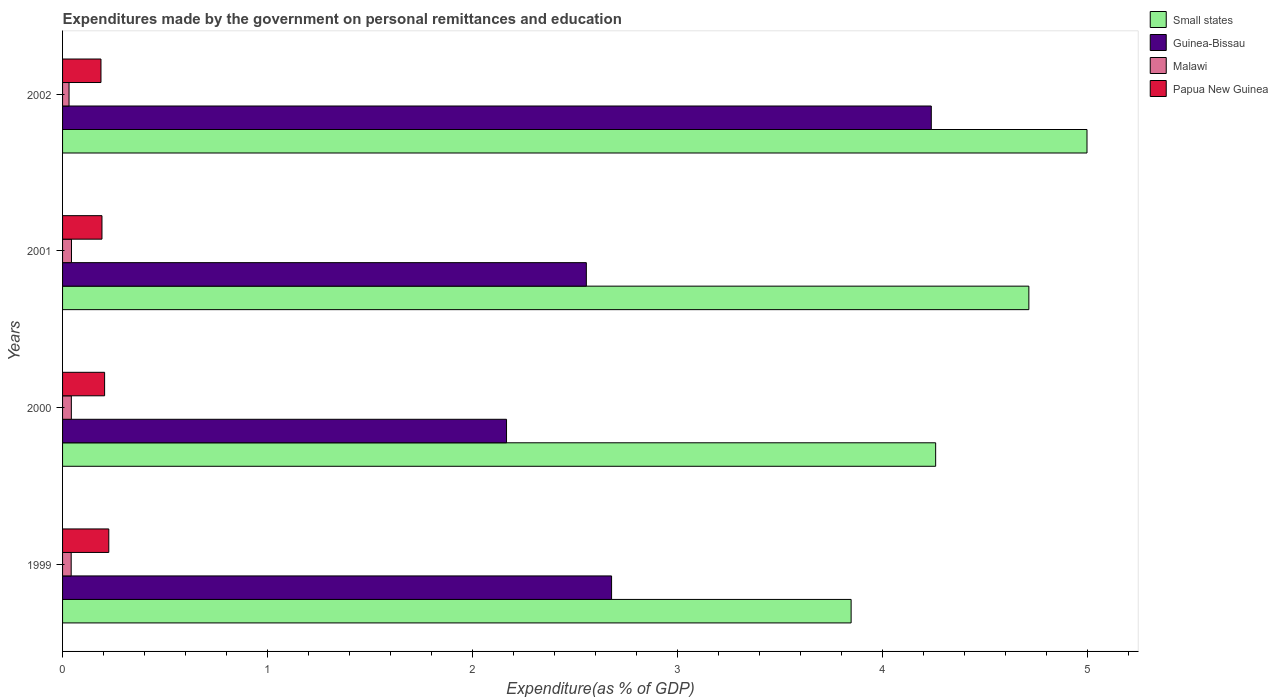How many groups of bars are there?
Your answer should be compact. 4. Are the number of bars per tick equal to the number of legend labels?
Keep it short and to the point. Yes. Are the number of bars on each tick of the Y-axis equal?
Your answer should be very brief. Yes. What is the label of the 4th group of bars from the top?
Offer a terse response. 1999. In how many cases, is the number of bars for a given year not equal to the number of legend labels?
Give a very brief answer. 0. What is the expenditures made by the government on personal remittances and education in Small states in 1999?
Keep it short and to the point. 3.85. Across all years, what is the maximum expenditures made by the government on personal remittances and education in Malawi?
Provide a succinct answer. 0.04. Across all years, what is the minimum expenditures made by the government on personal remittances and education in Papua New Guinea?
Offer a terse response. 0.19. In which year was the expenditures made by the government on personal remittances and education in Malawi maximum?
Your answer should be compact. 2001. In which year was the expenditures made by the government on personal remittances and education in Malawi minimum?
Offer a terse response. 2002. What is the total expenditures made by the government on personal remittances and education in Papua New Guinea in the graph?
Your answer should be compact. 0.81. What is the difference between the expenditures made by the government on personal remittances and education in Malawi in 2001 and that in 2002?
Make the answer very short. 0.01. What is the difference between the expenditures made by the government on personal remittances and education in Malawi in 2000 and the expenditures made by the government on personal remittances and education in Papua New Guinea in 2002?
Your answer should be compact. -0.14. What is the average expenditures made by the government on personal remittances and education in Guinea-Bissau per year?
Make the answer very short. 2.91. In the year 2000, what is the difference between the expenditures made by the government on personal remittances and education in Small states and expenditures made by the government on personal remittances and education in Malawi?
Offer a terse response. 4.22. What is the ratio of the expenditures made by the government on personal remittances and education in Papua New Guinea in 2000 to that in 2002?
Ensure brevity in your answer.  1.09. Is the difference between the expenditures made by the government on personal remittances and education in Small states in 2001 and 2002 greater than the difference between the expenditures made by the government on personal remittances and education in Malawi in 2001 and 2002?
Offer a terse response. No. What is the difference between the highest and the second highest expenditures made by the government on personal remittances and education in Malawi?
Provide a short and direct response. 0. What is the difference between the highest and the lowest expenditures made by the government on personal remittances and education in Small states?
Provide a succinct answer. 1.15. In how many years, is the expenditures made by the government on personal remittances and education in Small states greater than the average expenditures made by the government on personal remittances and education in Small states taken over all years?
Provide a short and direct response. 2. Is the sum of the expenditures made by the government on personal remittances and education in Papua New Guinea in 1999 and 2001 greater than the maximum expenditures made by the government on personal remittances and education in Small states across all years?
Ensure brevity in your answer.  No. Is it the case that in every year, the sum of the expenditures made by the government on personal remittances and education in Papua New Guinea and expenditures made by the government on personal remittances and education in Malawi is greater than the sum of expenditures made by the government on personal remittances and education in Small states and expenditures made by the government on personal remittances and education in Guinea-Bissau?
Offer a terse response. Yes. What does the 1st bar from the top in 2001 represents?
Your response must be concise. Papua New Guinea. What does the 3rd bar from the bottom in 2001 represents?
Offer a very short reply. Malawi. Is it the case that in every year, the sum of the expenditures made by the government on personal remittances and education in Small states and expenditures made by the government on personal remittances and education in Papua New Guinea is greater than the expenditures made by the government on personal remittances and education in Guinea-Bissau?
Offer a very short reply. Yes. Are all the bars in the graph horizontal?
Keep it short and to the point. Yes. How many years are there in the graph?
Provide a succinct answer. 4. Are the values on the major ticks of X-axis written in scientific E-notation?
Your answer should be very brief. No. Does the graph contain any zero values?
Your response must be concise. No. How many legend labels are there?
Provide a short and direct response. 4. How are the legend labels stacked?
Offer a terse response. Vertical. What is the title of the graph?
Offer a very short reply. Expenditures made by the government on personal remittances and education. What is the label or title of the X-axis?
Your answer should be very brief. Expenditure(as % of GDP). What is the label or title of the Y-axis?
Offer a terse response. Years. What is the Expenditure(as % of GDP) of Small states in 1999?
Give a very brief answer. 3.85. What is the Expenditure(as % of GDP) in Guinea-Bissau in 1999?
Ensure brevity in your answer.  2.68. What is the Expenditure(as % of GDP) of Malawi in 1999?
Provide a short and direct response. 0.04. What is the Expenditure(as % of GDP) of Papua New Guinea in 1999?
Your answer should be compact. 0.23. What is the Expenditure(as % of GDP) in Small states in 2000?
Provide a succinct answer. 4.26. What is the Expenditure(as % of GDP) in Guinea-Bissau in 2000?
Offer a very short reply. 2.17. What is the Expenditure(as % of GDP) of Malawi in 2000?
Provide a succinct answer. 0.04. What is the Expenditure(as % of GDP) of Papua New Guinea in 2000?
Make the answer very short. 0.21. What is the Expenditure(as % of GDP) of Small states in 2001?
Provide a short and direct response. 4.72. What is the Expenditure(as % of GDP) in Guinea-Bissau in 2001?
Your answer should be compact. 2.56. What is the Expenditure(as % of GDP) in Malawi in 2001?
Provide a short and direct response. 0.04. What is the Expenditure(as % of GDP) of Papua New Guinea in 2001?
Your answer should be compact. 0.19. What is the Expenditure(as % of GDP) of Small states in 2002?
Offer a terse response. 5. What is the Expenditure(as % of GDP) in Guinea-Bissau in 2002?
Make the answer very short. 4.24. What is the Expenditure(as % of GDP) of Malawi in 2002?
Offer a terse response. 0.03. What is the Expenditure(as % of GDP) in Papua New Guinea in 2002?
Ensure brevity in your answer.  0.19. Across all years, what is the maximum Expenditure(as % of GDP) of Small states?
Offer a very short reply. 5. Across all years, what is the maximum Expenditure(as % of GDP) in Guinea-Bissau?
Offer a terse response. 4.24. Across all years, what is the maximum Expenditure(as % of GDP) of Malawi?
Offer a very short reply. 0.04. Across all years, what is the maximum Expenditure(as % of GDP) in Papua New Guinea?
Your response must be concise. 0.23. Across all years, what is the minimum Expenditure(as % of GDP) of Small states?
Keep it short and to the point. 3.85. Across all years, what is the minimum Expenditure(as % of GDP) of Guinea-Bissau?
Offer a very short reply. 2.17. Across all years, what is the minimum Expenditure(as % of GDP) of Malawi?
Make the answer very short. 0.03. Across all years, what is the minimum Expenditure(as % of GDP) of Papua New Guinea?
Give a very brief answer. 0.19. What is the total Expenditure(as % of GDP) in Small states in the graph?
Offer a terse response. 17.83. What is the total Expenditure(as % of GDP) in Guinea-Bissau in the graph?
Keep it short and to the point. 11.64. What is the total Expenditure(as % of GDP) of Malawi in the graph?
Keep it short and to the point. 0.16. What is the total Expenditure(as % of GDP) in Papua New Guinea in the graph?
Your answer should be compact. 0.81. What is the difference between the Expenditure(as % of GDP) of Small states in 1999 and that in 2000?
Your response must be concise. -0.41. What is the difference between the Expenditure(as % of GDP) of Guinea-Bissau in 1999 and that in 2000?
Offer a very short reply. 0.51. What is the difference between the Expenditure(as % of GDP) of Malawi in 1999 and that in 2000?
Your answer should be very brief. -0. What is the difference between the Expenditure(as % of GDP) of Papua New Guinea in 1999 and that in 2000?
Provide a short and direct response. 0.02. What is the difference between the Expenditure(as % of GDP) in Small states in 1999 and that in 2001?
Provide a succinct answer. -0.87. What is the difference between the Expenditure(as % of GDP) of Guinea-Bissau in 1999 and that in 2001?
Make the answer very short. 0.12. What is the difference between the Expenditure(as % of GDP) of Malawi in 1999 and that in 2001?
Your answer should be very brief. -0. What is the difference between the Expenditure(as % of GDP) of Papua New Guinea in 1999 and that in 2001?
Your response must be concise. 0.03. What is the difference between the Expenditure(as % of GDP) of Small states in 1999 and that in 2002?
Offer a terse response. -1.15. What is the difference between the Expenditure(as % of GDP) of Guinea-Bissau in 1999 and that in 2002?
Your response must be concise. -1.56. What is the difference between the Expenditure(as % of GDP) in Malawi in 1999 and that in 2002?
Your answer should be very brief. 0.01. What is the difference between the Expenditure(as % of GDP) in Papua New Guinea in 1999 and that in 2002?
Provide a short and direct response. 0.04. What is the difference between the Expenditure(as % of GDP) of Small states in 2000 and that in 2001?
Your response must be concise. -0.45. What is the difference between the Expenditure(as % of GDP) in Guinea-Bissau in 2000 and that in 2001?
Offer a terse response. -0.39. What is the difference between the Expenditure(as % of GDP) of Malawi in 2000 and that in 2001?
Your answer should be compact. -0. What is the difference between the Expenditure(as % of GDP) in Papua New Guinea in 2000 and that in 2001?
Offer a very short reply. 0.01. What is the difference between the Expenditure(as % of GDP) of Small states in 2000 and that in 2002?
Make the answer very short. -0.74. What is the difference between the Expenditure(as % of GDP) of Guinea-Bissau in 2000 and that in 2002?
Give a very brief answer. -2.07. What is the difference between the Expenditure(as % of GDP) in Malawi in 2000 and that in 2002?
Make the answer very short. 0.01. What is the difference between the Expenditure(as % of GDP) of Papua New Guinea in 2000 and that in 2002?
Provide a succinct answer. 0.02. What is the difference between the Expenditure(as % of GDP) in Small states in 2001 and that in 2002?
Provide a succinct answer. -0.28. What is the difference between the Expenditure(as % of GDP) in Guinea-Bissau in 2001 and that in 2002?
Provide a succinct answer. -1.68. What is the difference between the Expenditure(as % of GDP) of Malawi in 2001 and that in 2002?
Provide a short and direct response. 0.01. What is the difference between the Expenditure(as % of GDP) of Papua New Guinea in 2001 and that in 2002?
Make the answer very short. 0. What is the difference between the Expenditure(as % of GDP) of Small states in 1999 and the Expenditure(as % of GDP) of Guinea-Bissau in 2000?
Offer a very short reply. 1.68. What is the difference between the Expenditure(as % of GDP) in Small states in 1999 and the Expenditure(as % of GDP) in Malawi in 2000?
Your answer should be compact. 3.81. What is the difference between the Expenditure(as % of GDP) of Small states in 1999 and the Expenditure(as % of GDP) of Papua New Guinea in 2000?
Make the answer very short. 3.64. What is the difference between the Expenditure(as % of GDP) of Guinea-Bissau in 1999 and the Expenditure(as % of GDP) of Malawi in 2000?
Give a very brief answer. 2.64. What is the difference between the Expenditure(as % of GDP) of Guinea-Bissau in 1999 and the Expenditure(as % of GDP) of Papua New Guinea in 2000?
Give a very brief answer. 2.47. What is the difference between the Expenditure(as % of GDP) of Malawi in 1999 and the Expenditure(as % of GDP) of Papua New Guinea in 2000?
Offer a very short reply. -0.16. What is the difference between the Expenditure(as % of GDP) of Small states in 1999 and the Expenditure(as % of GDP) of Guinea-Bissau in 2001?
Make the answer very short. 1.29. What is the difference between the Expenditure(as % of GDP) of Small states in 1999 and the Expenditure(as % of GDP) of Malawi in 2001?
Make the answer very short. 3.81. What is the difference between the Expenditure(as % of GDP) in Small states in 1999 and the Expenditure(as % of GDP) in Papua New Guinea in 2001?
Provide a succinct answer. 3.66. What is the difference between the Expenditure(as % of GDP) of Guinea-Bissau in 1999 and the Expenditure(as % of GDP) of Malawi in 2001?
Give a very brief answer. 2.64. What is the difference between the Expenditure(as % of GDP) in Guinea-Bissau in 1999 and the Expenditure(as % of GDP) in Papua New Guinea in 2001?
Give a very brief answer. 2.49. What is the difference between the Expenditure(as % of GDP) of Malawi in 1999 and the Expenditure(as % of GDP) of Papua New Guinea in 2001?
Give a very brief answer. -0.15. What is the difference between the Expenditure(as % of GDP) of Small states in 1999 and the Expenditure(as % of GDP) of Guinea-Bissau in 2002?
Offer a very short reply. -0.39. What is the difference between the Expenditure(as % of GDP) in Small states in 1999 and the Expenditure(as % of GDP) in Malawi in 2002?
Keep it short and to the point. 3.82. What is the difference between the Expenditure(as % of GDP) of Small states in 1999 and the Expenditure(as % of GDP) of Papua New Guinea in 2002?
Offer a very short reply. 3.66. What is the difference between the Expenditure(as % of GDP) of Guinea-Bissau in 1999 and the Expenditure(as % of GDP) of Malawi in 2002?
Provide a succinct answer. 2.65. What is the difference between the Expenditure(as % of GDP) of Guinea-Bissau in 1999 and the Expenditure(as % of GDP) of Papua New Guinea in 2002?
Your answer should be very brief. 2.49. What is the difference between the Expenditure(as % of GDP) in Malawi in 1999 and the Expenditure(as % of GDP) in Papua New Guinea in 2002?
Keep it short and to the point. -0.15. What is the difference between the Expenditure(as % of GDP) in Small states in 2000 and the Expenditure(as % of GDP) in Guinea-Bissau in 2001?
Provide a short and direct response. 1.7. What is the difference between the Expenditure(as % of GDP) in Small states in 2000 and the Expenditure(as % of GDP) in Malawi in 2001?
Offer a very short reply. 4.22. What is the difference between the Expenditure(as % of GDP) of Small states in 2000 and the Expenditure(as % of GDP) of Papua New Guinea in 2001?
Your response must be concise. 4.07. What is the difference between the Expenditure(as % of GDP) of Guinea-Bissau in 2000 and the Expenditure(as % of GDP) of Malawi in 2001?
Provide a short and direct response. 2.12. What is the difference between the Expenditure(as % of GDP) of Guinea-Bissau in 2000 and the Expenditure(as % of GDP) of Papua New Guinea in 2001?
Make the answer very short. 1.97. What is the difference between the Expenditure(as % of GDP) of Malawi in 2000 and the Expenditure(as % of GDP) of Papua New Guinea in 2001?
Make the answer very short. -0.15. What is the difference between the Expenditure(as % of GDP) of Small states in 2000 and the Expenditure(as % of GDP) of Guinea-Bissau in 2002?
Give a very brief answer. 0.02. What is the difference between the Expenditure(as % of GDP) of Small states in 2000 and the Expenditure(as % of GDP) of Malawi in 2002?
Your answer should be very brief. 4.23. What is the difference between the Expenditure(as % of GDP) in Small states in 2000 and the Expenditure(as % of GDP) in Papua New Guinea in 2002?
Your response must be concise. 4.07. What is the difference between the Expenditure(as % of GDP) in Guinea-Bissau in 2000 and the Expenditure(as % of GDP) in Malawi in 2002?
Keep it short and to the point. 2.14. What is the difference between the Expenditure(as % of GDP) in Guinea-Bissau in 2000 and the Expenditure(as % of GDP) in Papua New Guinea in 2002?
Keep it short and to the point. 1.98. What is the difference between the Expenditure(as % of GDP) of Malawi in 2000 and the Expenditure(as % of GDP) of Papua New Guinea in 2002?
Offer a very short reply. -0.14. What is the difference between the Expenditure(as % of GDP) of Small states in 2001 and the Expenditure(as % of GDP) of Guinea-Bissau in 2002?
Provide a succinct answer. 0.48. What is the difference between the Expenditure(as % of GDP) in Small states in 2001 and the Expenditure(as % of GDP) in Malawi in 2002?
Offer a terse response. 4.68. What is the difference between the Expenditure(as % of GDP) of Small states in 2001 and the Expenditure(as % of GDP) of Papua New Guinea in 2002?
Your response must be concise. 4.53. What is the difference between the Expenditure(as % of GDP) in Guinea-Bissau in 2001 and the Expenditure(as % of GDP) in Malawi in 2002?
Your answer should be compact. 2.52. What is the difference between the Expenditure(as % of GDP) in Guinea-Bissau in 2001 and the Expenditure(as % of GDP) in Papua New Guinea in 2002?
Provide a short and direct response. 2.37. What is the difference between the Expenditure(as % of GDP) of Malawi in 2001 and the Expenditure(as % of GDP) of Papua New Guinea in 2002?
Ensure brevity in your answer.  -0.14. What is the average Expenditure(as % of GDP) in Small states per year?
Offer a very short reply. 4.46. What is the average Expenditure(as % of GDP) of Guinea-Bissau per year?
Offer a terse response. 2.91. What is the average Expenditure(as % of GDP) in Malawi per year?
Make the answer very short. 0.04. What is the average Expenditure(as % of GDP) of Papua New Guinea per year?
Give a very brief answer. 0.2. In the year 1999, what is the difference between the Expenditure(as % of GDP) in Small states and Expenditure(as % of GDP) in Guinea-Bissau?
Your response must be concise. 1.17. In the year 1999, what is the difference between the Expenditure(as % of GDP) of Small states and Expenditure(as % of GDP) of Malawi?
Provide a short and direct response. 3.81. In the year 1999, what is the difference between the Expenditure(as % of GDP) of Small states and Expenditure(as % of GDP) of Papua New Guinea?
Ensure brevity in your answer.  3.62. In the year 1999, what is the difference between the Expenditure(as % of GDP) in Guinea-Bissau and Expenditure(as % of GDP) in Malawi?
Offer a terse response. 2.64. In the year 1999, what is the difference between the Expenditure(as % of GDP) in Guinea-Bissau and Expenditure(as % of GDP) in Papua New Guinea?
Your answer should be very brief. 2.45. In the year 1999, what is the difference between the Expenditure(as % of GDP) in Malawi and Expenditure(as % of GDP) in Papua New Guinea?
Offer a terse response. -0.18. In the year 2000, what is the difference between the Expenditure(as % of GDP) of Small states and Expenditure(as % of GDP) of Guinea-Bissau?
Keep it short and to the point. 2.09. In the year 2000, what is the difference between the Expenditure(as % of GDP) of Small states and Expenditure(as % of GDP) of Malawi?
Give a very brief answer. 4.22. In the year 2000, what is the difference between the Expenditure(as % of GDP) of Small states and Expenditure(as % of GDP) of Papua New Guinea?
Give a very brief answer. 4.06. In the year 2000, what is the difference between the Expenditure(as % of GDP) in Guinea-Bissau and Expenditure(as % of GDP) in Malawi?
Your answer should be very brief. 2.12. In the year 2000, what is the difference between the Expenditure(as % of GDP) in Guinea-Bissau and Expenditure(as % of GDP) in Papua New Guinea?
Offer a terse response. 1.96. In the year 2000, what is the difference between the Expenditure(as % of GDP) in Malawi and Expenditure(as % of GDP) in Papua New Guinea?
Your answer should be very brief. -0.16. In the year 2001, what is the difference between the Expenditure(as % of GDP) in Small states and Expenditure(as % of GDP) in Guinea-Bissau?
Offer a terse response. 2.16. In the year 2001, what is the difference between the Expenditure(as % of GDP) of Small states and Expenditure(as % of GDP) of Malawi?
Offer a terse response. 4.67. In the year 2001, what is the difference between the Expenditure(as % of GDP) of Small states and Expenditure(as % of GDP) of Papua New Guinea?
Your answer should be very brief. 4.52. In the year 2001, what is the difference between the Expenditure(as % of GDP) of Guinea-Bissau and Expenditure(as % of GDP) of Malawi?
Your answer should be compact. 2.51. In the year 2001, what is the difference between the Expenditure(as % of GDP) in Guinea-Bissau and Expenditure(as % of GDP) in Papua New Guinea?
Offer a terse response. 2.36. In the year 2001, what is the difference between the Expenditure(as % of GDP) in Malawi and Expenditure(as % of GDP) in Papua New Guinea?
Keep it short and to the point. -0.15. In the year 2002, what is the difference between the Expenditure(as % of GDP) in Small states and Expenditure(as % of GDP) in Guinea-Bissau?
Provide a succinct answer. 0.76. In the year 2002, what is the difference between the Expenditure(as % of GDP) in Small states and Expenditure(as % of GDP) in Malawi?
Your answer should be compact. 4.97. In the year 2002, what is the difference between the Expenditure(as % of GDP) of Small states and Expenditure(as % of GDP) of Papua New Guinea?
Your answer should be very brief. 4.81. In the year 2002, what is the difference between the Expenditure(as % of GDP) in Guinea-Bissau and Expenditure(as % of GDP) in Malawi?
Offer a terse response. 4.21. In the year 2002, what is the difference between the Expenditure(as % of GDP) in Guinea-Bissau and Expenditure(as % of GDP) in Papua New Guinea?
Provide a succinct answer. 4.05. In the year 2002, what is the difference between the Expenditure(as % of GDP) of Malawi and Expenditure(as % of GDP) of Papua New Guinea?
Give a very brief answer. -0.16. What is the ratio of the Expenditure(as % of GDP) in Small states in 1999 to that in 2000?
Offer a very short reply. 0.9. What is the ratio of the Expenditure(as % of GDP) in Guinea-Bissau in 1999 to that in 2000?
Give a very brief answer. 1.24. What is the ratio of the Expenditure(as % of GDP) of Malawi in 1999 to that in 2000?
Keep it short and to the point. 0.98. What is the ratio of the Expenditure(as % of GDP) of Papua New Guinea in 1999 to that in 2000?
Ensure brevity in your answer.  1.1. What is the ratio of the Expenditure(as % of GDP) in Small states in 1999 to that in 2001?
Provide a short and direct response. 0.82. What is the ratio of the Expenditure(as % of GDP) of Guinea-Bissau in 1999 to that in 2001?
Offer a very short reply. 1.05. What is the ratio of the Expenditure(as % of GDP) in Malawi in 1999 to that in 2001?
Offer a very short reply. 0.97. What is the ratio of the Expenditure(as % of GDP) of Papua New Guinea in 1999 to that in 2001?
Provide a succinct answer. 1.17. What is the ratio of the Expenditure(as % of GDP) in Small states in 1999 to that in 2002?
Offer a terse response. 0.77. What is the ratio of the Expenditure(as % of GDP) in Guinea-Bissau in 1999 to that in 2002?
Your answer should be compact. 0.63. What is the ratio of the Expenditure(as % of GDP) in Malawi in 1999 to that in 2002?
Your answer should be compact. 1.33. What is the ratio of the Expenditure(as % of GDP) in Papua New Guinea in 1999 to that in 2002?
Provide a short and direct response. 1.2. What is the ratio of the Expenditure(as % of GDP) of Small states in 2000 to that in 2001?
Provide a succinct answer. 0.9. What is the ratio of the Expenditure(as % of GDP) of Guinea-Bissau in 2000 to that in 2001?
Your response must be concise. 0.85. What is the ratio of the Expenditure(as % of GDP) in Malawi in 2000 to that in 2001?
Provide a succinct answer. 0.98. What is the ratio of the Expenditure(as % of GDP) in Papua New Guinea in 2000 to that in 2001?
Provide a short and direct response. 1.07. What is the ratio of the Expenditure(as % of GDP) of Small states in 2000 to that in 2002?
Your answer should be compact. 0.85. What is the ratio of the Expenditure(as % of GDP) of Guinea-Bissau in 2000 to that in 2002?
Keep it short and to the point. 0.51. What is the ratio of the Expenditure(as % of GDP) in Malawi in 2000 to that in 2002?
Keep it short and to the point. 1.35. What is the ratio of the Expenditure(as % of GDP) of Papua New Guinea in 2000 to that in 2002?
Offer a very short reply. 1.09. What is the ratio of the Expenditure(as % of GDP) of Small states in 2001 to that in 2002?
Give a very brief answer. 0.94. What is the ratio of the Expenditure(as % of GDP) in Guinea-Bissau in 2001 to that in 2002?
Provide a short and direct response. 0.6. What is the ratio of the Expenditure(as % of GDP) in Malawi in 2001 to that in 2002?
Offer a terse response. 1.37. What is the ratio of the Expenditure(as % of GDP) of Papua New Guinea in 2001 to that in 2002?
Your answer should be compact. 1.03. What is the difference between the highest and the second highest Expenditure(as % of GDP) of Small states?
Ensure brevity in your answer.  0.28. What is the difference between the highest and the second highest Expenditure(as % of GDP) in Guinea-Bissau?
Your answer should be very brief. 1.56. What is the difference between the highest and the second highest Expenditure(as % of GDP) of Malawi?
Provide a short and direct response. 0. What is the difference between the highest and the second highest Expenditure(as % of GDP) in Papua New Guinea?
Provide a short and direct response. 0.02. What is the difference between the highest and the lowest Expenditure(as % of GDP) in Small states?
Keep it short and to the point. 1.15. What is the difference between the highest and the lowest Expenditure(as % of GDP) in Guinea-Bissau?
Offer a very short reply. 2.07. What is the difference between the highest and the lowest Expenditure(as % of GDP) of Malawi?
Make the answer very short. 0.01. What is the difference between the highest and the lowest Expenditure(as % of GDP) in Papua New Guinea?
Your answer should be very brief. 0.04. 